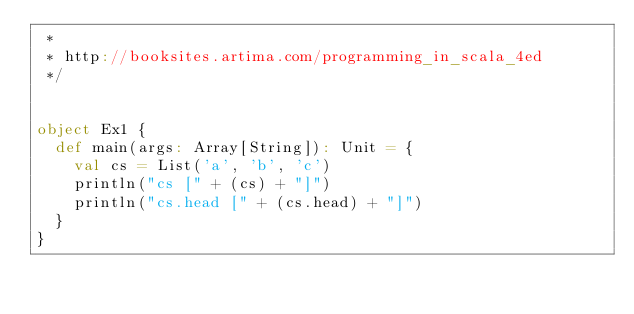Convert code to text. <code><loc_0><loc_0><loc_500><loc_500><_Scala_> *
 * http://booksites.artima.com/programming_in_scala_4ed
 */


object Ex1 {
  def main(args: Array[String]): Unit = {
    val cs = List('a', 'b', 'c')
    println("cs [" + (cs) + "]")
    println("cs.head [" + (cs.head) + "]")
  }
}
</code> 